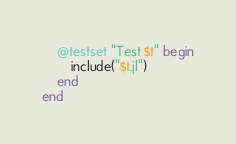Convert code to text. <code><loc_0><loc_0><loc_500><loc_500><_Julia_>    @testset "Test $t" begin
        include("$t.jl")
    end
end
</code> 